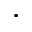Convert formula to latex. <formula><loc_0><loc_0><loc_500><loc_500>\cdot</formula> 